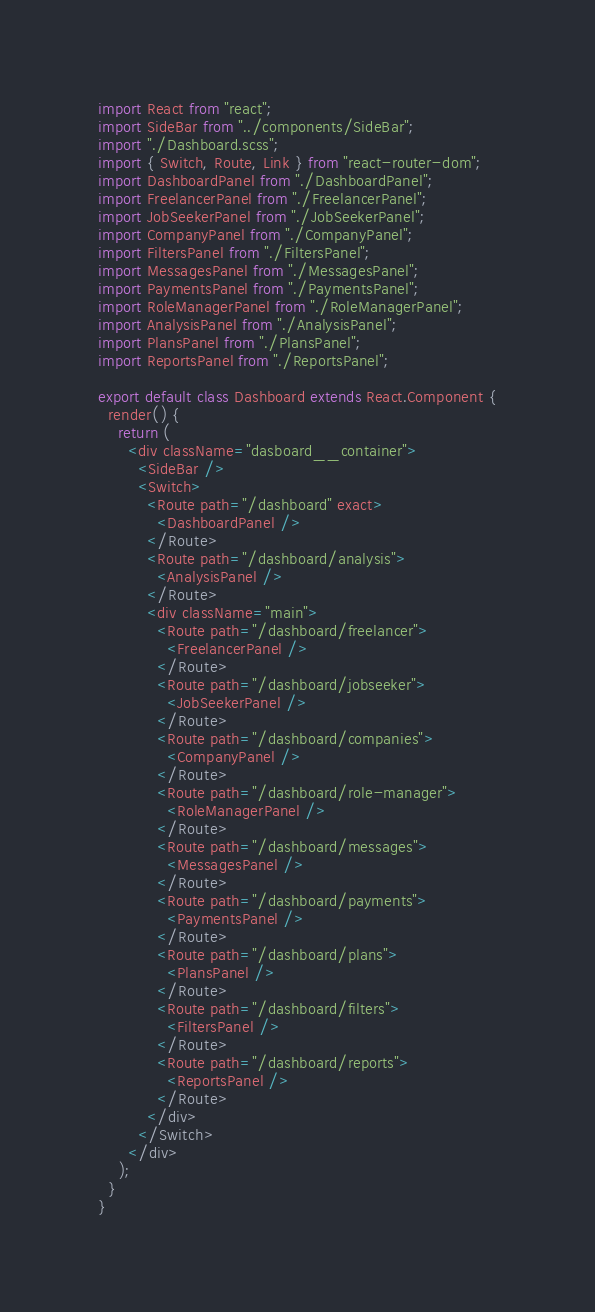Convert code to text. <code><loc_0><loc_0><loc_500><loc_500><_JavaScript_>import React from "react";
import SideBar from "../components/SideBar";
import "./Dashboard.scss";
import { Switch, Route, Link } from "react-router-dom";
import DashboardPanel from "./DashboardPanel";
import FreelancerPanel from "./FreelancerPanel";
import JobSeekerPanel from "./JobSeekerPanel";
import CompanyPanel from "./CompanyPanel";
import FiltersPanel from "./FiltersPanel";
import MessagesPanel from "./MessagesPanel";
import PaymentsPanel from "./PaymentsPanel";
import RoleManagerPanel from "./RoleManagerPanel";
import AnalysisPanel from "./AnalysisPanel";
import PlansPanel from "./PlansPanel";
import ReportsPanel from "./ReportsPanel";

export default class Dashboard extends React.Component {
  render() {
    return (
      <div className="dasboard__container">
        <SideBar />
        <Switch>
          <Route path="/dashboard" exact>
            <DashboardPanel />
          </Route>
          <Route path="/dashboard/analysis">
            <AnalysisPanel />
          </Route>
          <div className="main">
            <Route path="/dashboard/freelancer">
              <FreelancerPanel />
            </Route>
            <Route path="/dashboard/jobseeker">
              <JobSeekerPanel />
            </Route>
            <Route path="/dashboard/companies">
              <CompanyPanel />
            </Route>
            <Route path="/dashboard/role-manager">
              <RoleManagerPanel />
            </Route>
            <Route path="/dashboard/messages">
              <MessagesPanel />
            </Route>
            <Route path="/dashboard/payments">
              <PaymentsPanel />
            </Route>
            <Route path="/dashboard/plans">
              <PlansPanel />
            </Route>
            <Route path="/dashboard/filters">
              <FiltersPanel />
            </Route>
            <Route path="/dashboard/reports">
              <ReportsPanel />
            </Route>
          </div>
        </Switch>
      </div>
    );
  }
}
</code> 